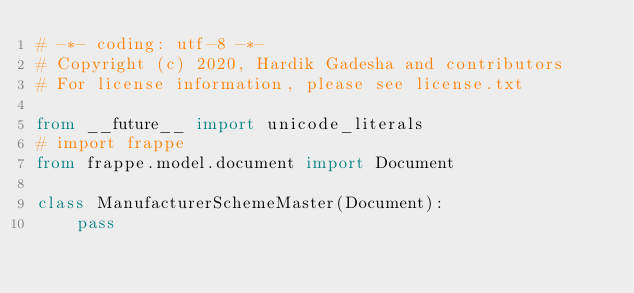<code> <loc_0><loc_0><loc_500><loc_500><_Python_># -*- coding: utf-8 -*-
# Copyright (c) 2020, Hardik Gadesha and contributors
# For license information, please see license.txt

from __future__ import unicode_literals
# import frappe
from frappe.model.document import Document

class ManufacturerSchemeMaster(Document):
	pass
</code> 